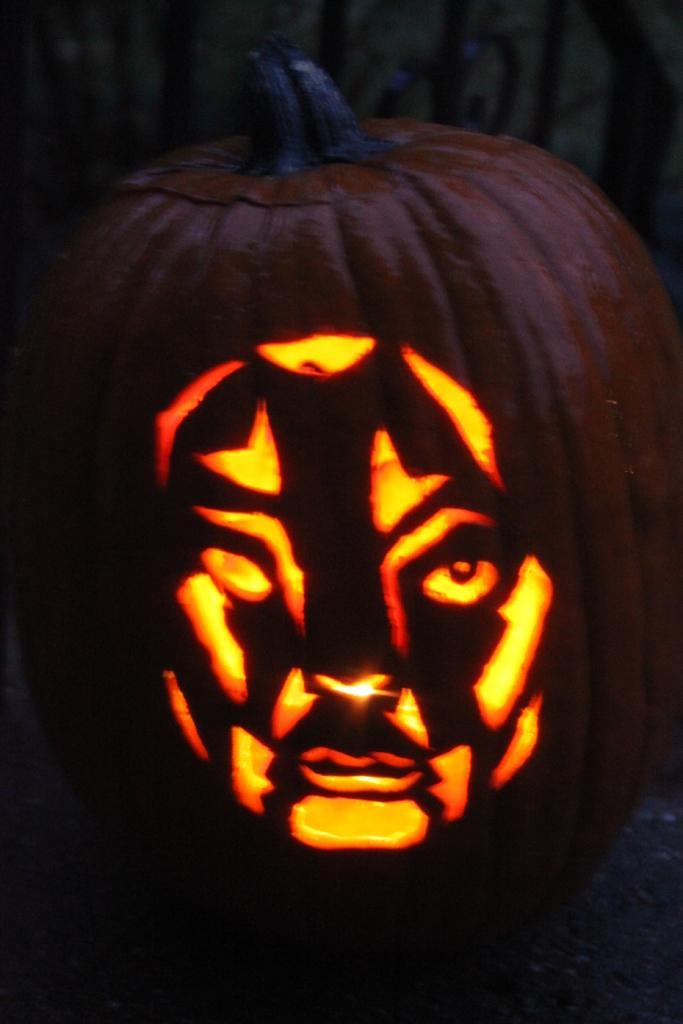What is the main subject of the image? The main subject of the image is a pumpkin. What is unique about the appearance of the pumpkin? The pumpkin has a design of a human face. Is there any illumination coming from the pumpkin? Yes, there is a light in the pumpkin. What can be seen at the top of the image? There is an object at the top of the image. What type of account can be seen being opened in the image? There is no account being opened in the image; it features a pumpkin with a human face design and a light inside. Can you describe the yard where the pumpkin is located in the image? The provided facts do not mention a yard or any outdoor setting, so it cannot be determined from the image. 